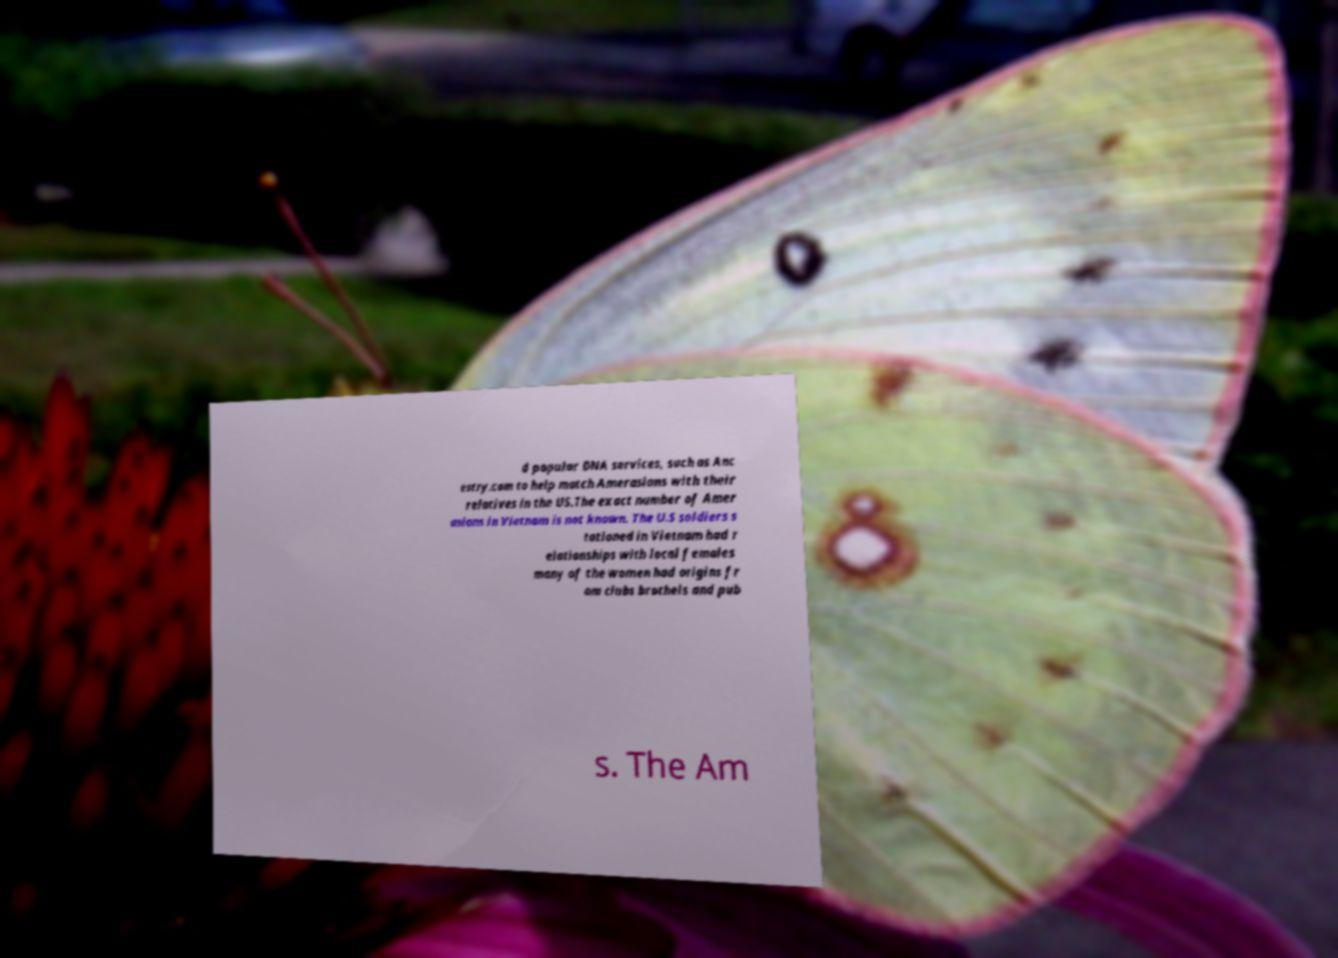Please identify and transcribe the text found in this image. d popular DNA services, such as Anc estry.com to help match Amerasians with their relatives in the US.The exact number of Amer asians in Vietnam is not known. The U.S soldiers s tationed in Vietnam had r elationships with local females many of the women had origins fr om clubs brothels and pub s. The Am 